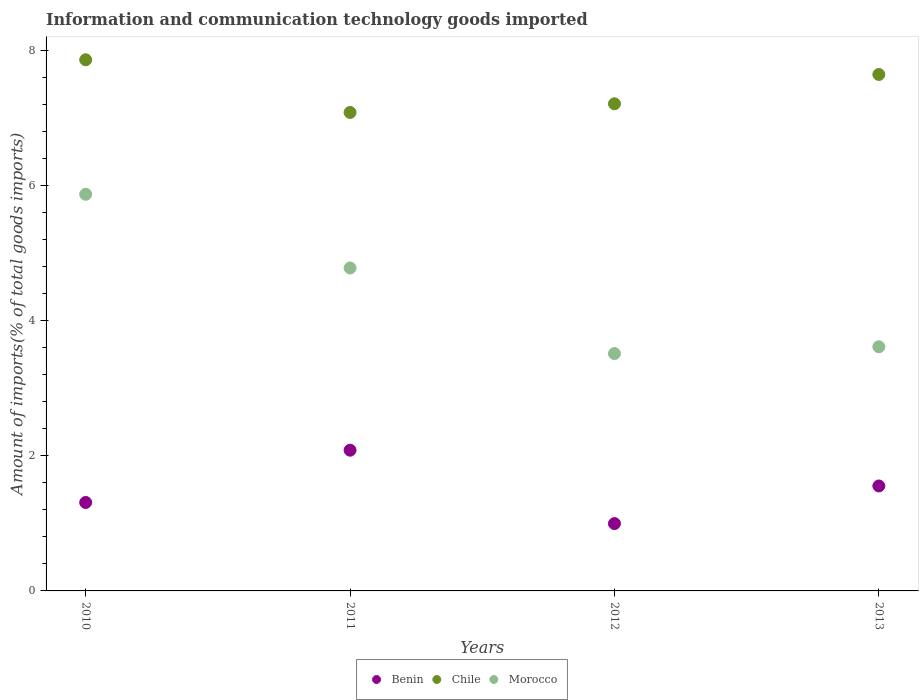What is the amount of goods imported in Morocco in 2012?
Ensure brevity in your answer.  3.51. Across all years, what is the maximum amount of goods imported in Chile?
Offer a terse response. 7.86. Across all years, what is the minimum amount of goods imported in Morocco?
Offer a terse response. 3.51. In which year was the amount of goods imported in Morocco maximum?
Your response must be concise. 2010. What is the total amount of goods imported in Chile in the graph?
Your answer should be compact. 29.78. What is the difference between the amount of goods imported in Benin in 2010 and that in 2012?
Your answer should be very brief. 0.31. What is the difference between the amount of goods imported in Morocco in 2010 and the amount of goods imported in Chile in 2012?
Your answer should be compact. -1.34. What is the average amount of goods imported in Chile per year?
Provide a succinct answer. 7.44. In the year 2013, what is the difference between the amount of goods imported in Morocco and amount of goods imported in Benin?
Provide a succinct answer. 2.06. What is the ratio of the amount of goods imported in Benin in 2011 to that in 2012?
Make the answer very short. 2.09. Is the amount of goods imported in Chile in 2010 less than that in 2011?
Provide a short and direct response. No. What is the difference between the highest and the second highest amount of goods imported in Chile?
Offer a terse response. 0.22. What is the difference between the highest and the lowest amount of goods imported in Chile?
Keep it short and to the point. 0.78. In how many years, is the amount of goods imported in Benin greater than the average amount of goods imported in Benin taken over all years?
Provide a succinct answer. 2. Is the sum of the amount of goods imported in Morocco in 2010 and 2011 greater than the maximum amount of goods imported in Chile across all years?
Offer a terse response. Yes. Is it the case that in every year, the sum of the amount of goods imported in Morocco and amount of goods imported in Chile  is greater than the amount of goods imported in Benin?
Offer a terse response. Yes. Is the amount of goods imported in Morocco strictly greater than the amount of goods imported in Chile over the years?
Make the answer very short. No. Is the amount of goods imported in Benin strictly less than the amount of goods imported in Chile over the years?
Make the answer very short. Yes. Does the graph contain grids?
Provide a succinct answer. No. Where does the legend appear in the graph?
Provide a short and direct response. Bottom center. How many legend labels are there?
Ensure brevity in your answer.  3. How are the legend labels stacked?
Provide a short and direct response. Horizontal. What is the title of the graph?
Keep it short and to the point. Information and communication technology goods imported. What is the label or title of the X-axis?
Ensure brevity in your answer.  Years. What is the label or title of the Y-axis?
Keep it short and to the point. Amount of imports(% of total goods imports). What is the Amount of imports(% of total goods imports) of Benin in 2010?
Keep it short and to the point. 1.31. What is the Amount of imports(% of total goods imports) of Chile in 2010?
Your answer should be very brief. 7.86. What is the Amount of imports(% of total goods imports) of Morocco in 2010?
Offer a very short reply. 5.87. What is the Amount of imports(% of total goods imports) in Benin in 2011?
Your answer should be compact. 2.08. What is the Amount of imports(% of total goods imports) in Chile in 2011?
Keep it short and to the point. 7.08. What is the Amount of imports(% of total goods imports) in Morocco in 2011?
Your answer should be compact. 4.78. What is the Amount of imports(% of total goods imports) in Benin in 2012?
Make the answer very short. 1. What is the Amount of imports(% of total goods imports) in Chile in 2012?
Your answer should be compact. 7.2. What is the Amount of imports(% of total goods imports) in Morocco in 2012?
Keep it short and to the point. 3.51. What is the Amount of imports(% of total goods imports) of Benin in 2013?
Keep it short and to the point. 1.55. What is the Amount of imports(% of total goods imports) in Chile in 2013?
Provide a succinct answer. 7.64. What is the Amount of imports(% of total goods imports) of Morocco in 2013?
Your response must be concise. 3.61. Across all years, what is the maximum Amount of imports(% of total goods imports) in Benin?
Offer a very short reply. 2.08. Across all years, what is the maximum Amount of imports(% of total goods imports) of Chile?
Your answer should be very brief. 7.86. Across all years, what is the maximum Amount of imports(% of total goods imports) of Morocco?
Provide a short and direct response. 5.87. Across all years, what is the minimum Amount of imports(% of total goods imports) in Benin?
Your response must be concise. 1. Across all years, what is the minimum Amount of imports(% of total goods imports) in Chile?
Offer a terse response. 7.08. Across all years, what is the minimum Amount of imports(% of total goods imports) in Morocco?
Provide a short and direct response. 3.51. What is the total Amount of imports(% of total goods imports) of Benin in the graph?
Offer a terse response. 5.94. What is the total Amount of imports(% of total goods imports) of Chile in the graph?
Offer a very short reply. 29.78. What is the total Amount of imports(% of total goods imports) in Morocco in the graph?
Provide a short and direct response. 17.76. What is the difference between the Amount of imports(% of total goods imports) in Benin in 2010 and that in 2011?
Your answer should be compact. -0.77. What is the difference between the Amount of imports(% of total goods imports) in Chile in 2010 and that in 2011?
Offer a very short reply. 0.78. What is the difference between the Amount of imports(% of total goods imports) of Morocco in 2010 and that in 2011?
Your answer should be very brief. 1.09. What is the difference between the Amount of imports(% of total goods imports) of Benin in 2010 and that in 2012?
Your response must be concise. 0.31. What is the difference between the Amount of imports(% of total goods imports) of Chile in 2010 and that in 2012?
Give a very brief answer. 0.65. What is the difference between the Amount of imports(% of total goods imports) in Morocco in 2010 and that in 2012?
Offer a very short reply. 2.36. What is the difference between the Amount of imports(% of total goods imports) in Benin in 2010 and that in 2013?
Your answer should be very brief. -0.24. What is the difference between the Amount of imports(% of total goods imports) in Chile in 2010 and that in 2013?
Provide a short and direct response. 0.22. What is the difference between the Amount of imports(% of total goods imports) in Morocco in 2010 and that in 2013?
Ensure brevity in your answer.  2.26. What is the difference between the Amount of imports(% of total goods imports) of Benin in 2011 and that in 2012?
Provide a succinct answer. 1.09. What is the difference between the Amount of imports(% of total goods imports) in Chile in 2011 and that in 2012?
Offer a very short reply. -0.13. What is the difference between the Amount of imports(% of total goods imports) of Morocco in 2011 and that in 2012?
Provide a succinct answer. 1.27. What is the difference between the Amount of imports(% of total goods imports) of Benin in 2011 and that in 2013?
Offer a very short reply. 0.53. What is the difference between the Amount of imports(% of total goods imports) of Chile in 2011 and that in 2013?
Keep it short and to the point. -0.56. What is the difference between the Amount of imports(% of total goods imports) of Morocco in 2011 and that in 2013?
Keep it short and to the point. 1.17. What is the difference between the Amount of imports(% of total goods imports) of Benin in 2012 and that in 2013?
Keep it short and to the point. -0.56. What is the difference between the Amount of imports(% of total goods imports) of Chile in 2012 and that in 2013?
Provide a short and direct response. -0.43. What is the difference between the Amount of imports(% of total goods imports) in Morocco in 2012 and that in 2013?
Offer a very short reply. -0.1. What is the difference between the Amount of imports(% of total goods imports) in Benin in 2010 and the Amount of imports(% of total goods imports) in Chile in 2011?
Give a very brief answer. -5.77. What is the difference between the Amount of imports(% of total goods imports) of Benin in 2010 and the Amount of imports(% of total goods imports) of Morocco in 2011?
Your answer should be very brief. -3.47. What is the difference between the Amount of imports(% of total goods imports) of Chile in 2010 and the Amount of imports(% of total goods imports) of Morocco in 2011?
Ensure brevity in your answer.  3.08. What is the difference between the Amount of imports(% of total goods imports) in Benin in 2010 and the Amount of imports(% of total goods imports) in Chile in 2012?
Your response must be concise. -5.9. What is the difference between the Amount of imports(% of total goods imports) in Benin in 2010 and the Amount of imports(% of total goods imports) in Morocco in 2012?
Offer a very short reply. -2.2. What is the difference between the Amount of imports(% of total goods imports) of Chile in 2010 and the Amount of imports(% of total goods imports) of Morocco in 2012?
Your response must be concise. 4.35. What is the difference between the Amount of imports(% of total goods imports) of Benin in 2010 and the Amount of imports(% of total goods imports) of Chile in 2013?
Your answer should be very brief. -6.33. What is the difference between the Amount of imports(% of total goods imports) of Benin in 2010 and the Amount of imports(% of total goods imports) of Morocco in 2013?
Your answer should be compact. -2.3. What is the difference between the Amount of imports(% of total goods imports) in Chile in 2010 and the Amount of imports(% of total goods imports) in Morocco in 2013?
Your answer should be compact. 4.24. What is the difference between the Amount of imports(% of total goods imports) of Benin in 2011 and the Amount of imports(% of total goods imports) of Chile in 2012?
Keep it short and to the point. -5.12. What is the difference between the Amount of imports(% of total goods imports) in Benin in 2011 and the Amount of imports(% of total goods imports) in Morocco in 2012?
Your answer should be very brief. -1.43. What is the difference between the Amount of imports(% of total goods imports) of Chile in 2011 and the Amount of imports(% of total goods imports) of Morocco in 2012?
Your answer should be very brief. 3.57. What is the difference between the Amount of imports(% of total goods imports) of Benin in 2011 and the Amount of imports(% of total goods imports) of Chile in 2013?
Keep it short and to the point. -5.56. What is the difference between the Amount of imports(% of total goods imports) in Benin in 2011 and the Amount of imports(% of total goods imports) in Morocco in 2013?
Your answer should be compact. -1.53. What is the difference between the Amount of imports(% of total goods imports) of Chile in 2011 and the Amount of imports(% of total goods imports) of Morocco in 2013?
Provide a short and direct response. 3.47. What is the difference between the Amount of imports(% of total goods imports) in Benin in 2012 and the Amount of imports(% of total goods imports) in Chile in 2013?
Make the answer very short. -6.64. What is the difference between the Amount of imports(% of total goods imports) of Benin in 2012 and the Amount of imports(% of total goods imports) of Morocco in 2013?
Keep it short and to the point. -2.62. What is the difference between the Amount of imports(% of total goods imports) of Chile in 2012 and the Amount of imports(% of total goods imports) of Morocco in 2013?
Your answer should be very brief. 3.59. What is the average Amount of imports(% of total goods imports) of Benin per year?
Your response must be concise. 1.48. What is the average Amount of imports(% of total goods imports) in Chile per year?
Ensure brevity in your answer.  7.44. What is the average Amount of imports(% of total goods imports) of Morocco per year?
Make the answer very short. 4.44. In the year 2010, what is the difference between the Amount of imports(% of total goods imports) in Benin and Amount of imports(% of total goods imports) in Chile?
Your answer should be very brief. -6.55. In the year 2010, what is the difference between the Amount of imports(% of total goods imports) of Benin and Amount of imports(% of total goods imports) of Morocco?
Offer a terse response. -4.56. In the year 2010, what is the difference between the Amount of imports(% of total goods imports) of Chile and Amount of imports(% of total goods imports) of Morocco?
Provide a succinct answer. 1.99. In the year 2011, what is the difference between the Amount of imports(% of total goods imports) in Benin and Amount of imports(% of total goods imports) in Chile?
Provide a succinct answer. -5. In the year 2011, what is the difference between the Amount of imports(% of total goods imports) of Benin and Amount of imports(% of total goods imports) of Morocco?
Your answer should be very brief. -2.7. In the year 2011, what is the difference between the Amount of imports(% of total goods imports) in Chile and Amount of imports(% of total goods imports) in Morocco?
Make the answer very short. 2.3. In the year 2012, what is the difference between the Amount of imports(% of total goods imports) in Benin and Amount of imports(% of total goods imports) in Chile?
Your answer should be very brief. -6.21. In the year 2012, what is the difference between the Amount of imports(% of total goods imports) in Benin and Amount of imports(% of total goods imports) in Morocco?
Make the answer very short. -2.51. In the year 2012, what is the difference between the Amount of imports(% of total goods imports) of Chile and Amount of imports(% of total goods imports) of Morocco?
Your response must be concise. 3.69. In the year 2013, what is the difference between the Amount of imports(% of total goods imports) in Benin and Amount of imports(% of total goods imports) in Chile?
Ensure brevity in your answer.  -6.09. In the year 2013, what is the difference between the Amount of imports(% of total goods imports) of Benin and Amount of imports(% of total goods imports) of Morocco?
Give a very brief answer. -2.06. In the year 2013, what is the difference between the Amount of imports(% of total goods imports) of Chile and Amount of imports(% of total goods imports) of Morocco?
Give a very brief answer. 4.03. What is the ratio of the Amount of imports(% of total goods imports) in Benin in 2010 to that in 2011?
Provide a succinct answer. 0.63. What is the ratio of the Amount of imports(% of total goods imports) of Chile in 2010 to that in 2011?
Provide a succinct answer. 1.11. What is the ratio of the Amount of imports(% of total goods imports) of Morocco in 2010 to that in 2011?
Keep it short and to the point. 1.23. What is the ratio of the Amount of imports(% of total goods imports) of Benin in 2010 to that in 2012?
Your answer should be very brief. 1.31. What is the ratio of the Amount of imports(% of total goods imports) in Chile in 2010 to that in 2012?
Provide a short and direct response. 1.09. What is the ratio of the Amount of imports(% of total goods imports) in Morocco in 2010 to that in 2012?
Your answer should be compact. 1.67. What is the ratio of the Amount of imports(% of total goods imports) of Benin in 2010 to that in 2013?
Offer a very short reply. 0.84. What is the ratio of the Amount of imports(% of total goods imports) of Chile in 2010 to that in 2013?
Provide a short and direct response. 1.03. What is the ratio of the Amount of imports(% of total goods imports) of Morocco in 2010 to that in 2013?
Your answer should be very brief. 1.62. What is the ratio of the Amount of imports(% of total goods imports) in Benin in 2011 to that in 2012?
Your response must be concise. 2.09. What is the ratio of the Amount of imports(% of total goods imports) of Chile in 2011 to that in 2012?
Give a very brief answer. 0.98. What is the ratio of the Amount of imports(% of total goods imports) of Morocco in 2011 to that in 2012?
Give a very brief answer. 1.36. What is the ratio of the Amount of imports(% of total goods imports) of Benin in 2011 to that in 2013?
Ensure brevity in your answer.  1.34. What is the ratio of the Amount of imports(% of total goods imports) in Chile in 2011 to that in 2013?
Keep it short and to the point. 0.93. What is the ratio of the Amount of imports(% of total goods imports) in Morocco in 2011 to that in 2013?
Your response must be concise. 1.32. What is the ratio of the Amount of imports(% of total goods imports) in Benin in 2012 to that in 2013?
Keep it short and to the point. 0.64. What is the ratio of the Amount of imports(% of total goods imports) in Chile in 2012 to that in 2013?
Ensure brevity in your answer.  0.94. What is the ratio of the Amount of imports(% of total goods imports) in Morocco in 2012 to that in 2013?
Ensure brevity in your answer.  0.97. What is the difference between the highest and the second highest Amount of imports(% of total goods imports) in Benin?
Provide a short and direct response. 0.53. What is the difference between the highest and the second highest Amount of imports(% of total goods imports) in Chile?
Your answer should be very brief. 0.22. What is the difference between the highest and the second highest Amount of imports(% of total goods imports) in Morocco?
Keep it short and to the point. 1.09. What is the difference between the highest and the lowest Amount of imports(% of total goods imports) in Benin?
Your answer should be compact. 1.09. What is the difference between the highest and the lowest Amount of imports(% of total goods imports) of Chile?
Ensure brevity in your answer.  0.78. What is the difference between the highest and the lowest Amount of imports(% of total goods imports) of Morocco?
Make the answer very short. 2.36. 